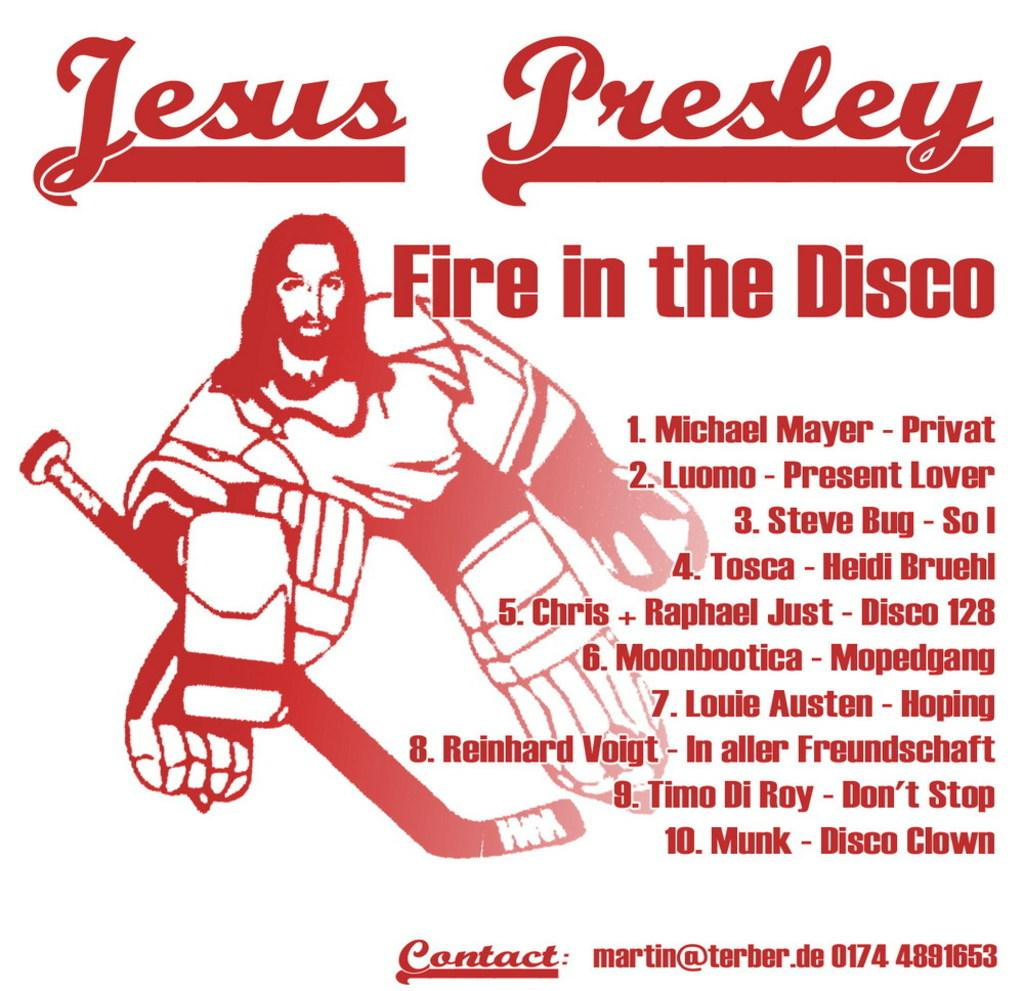<image>
Describe the image concisely. picture of jesus in hockey gear for jesus presley album fire in the disco and its 10 songs 